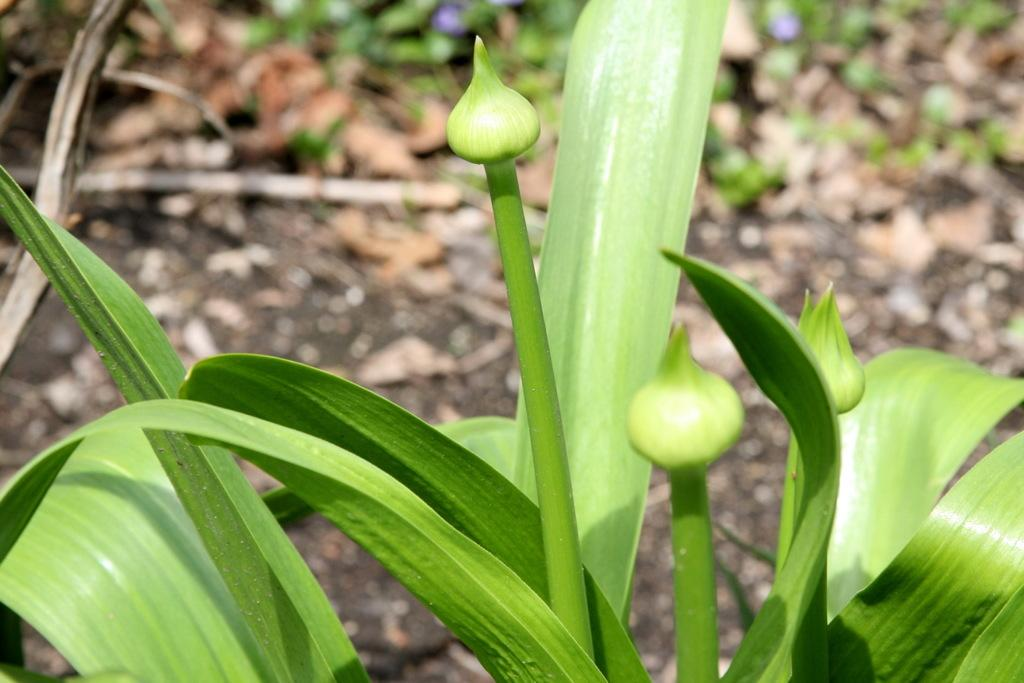What color are the leaves in the image? The leaves in the image are green. What structural features can be observed on the leaves? The leaves have stems. Are there any additional features on the leaves? Yes, there are buds on the leaves. How would you describe the background of the image? The background of the image is blurred. What type of bells can be heard ringing in the image? There are no bells present in the image, so it is not possible to hear them ringing. 